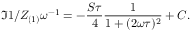<formula> <loc_0><loc_0><loc_500><loc_500>\Im { 1 / Z _ { ( 1 ) } } \omega ^ { - 1 } = - \frac { S \tau } { 4 } \frac { 1 } { 1 + ( 2 \omega \tau ) ^ { 2 } } + C .</formula> 